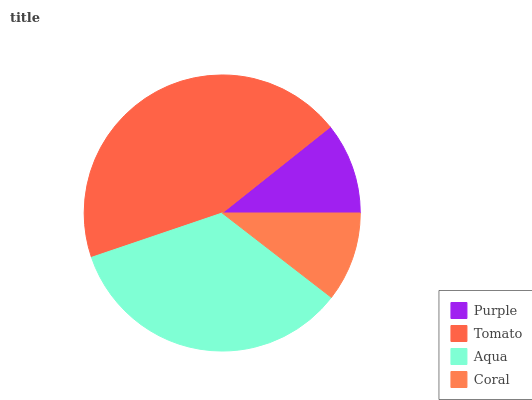Is Coral the minimum?
Answer yes or no. Yes. Is Tomato the maximum?
Answer yes or no. Yes. Is Aqua the minimum?
Answer yes or no. No. Is Aqua the maximum?
Answer yes or no. No. Is Tomato greater than Aqua?
Answer yes or no. Yes. Is Aqua less than Tomato?
Answer yes or no. Yes. Is Aqua greater than Tomato?
Answer yes or no. No. Is Tomato less than Aqua?
Answer yes or no. No. Is Aqua the high median?
Answer yes or no. Yes. Is Purple the low median?
Answer yes or no. Yes. Is Coral the high median?
Answer yes or no. No. Is Aqua the low median?
Answer yes or no. No. 